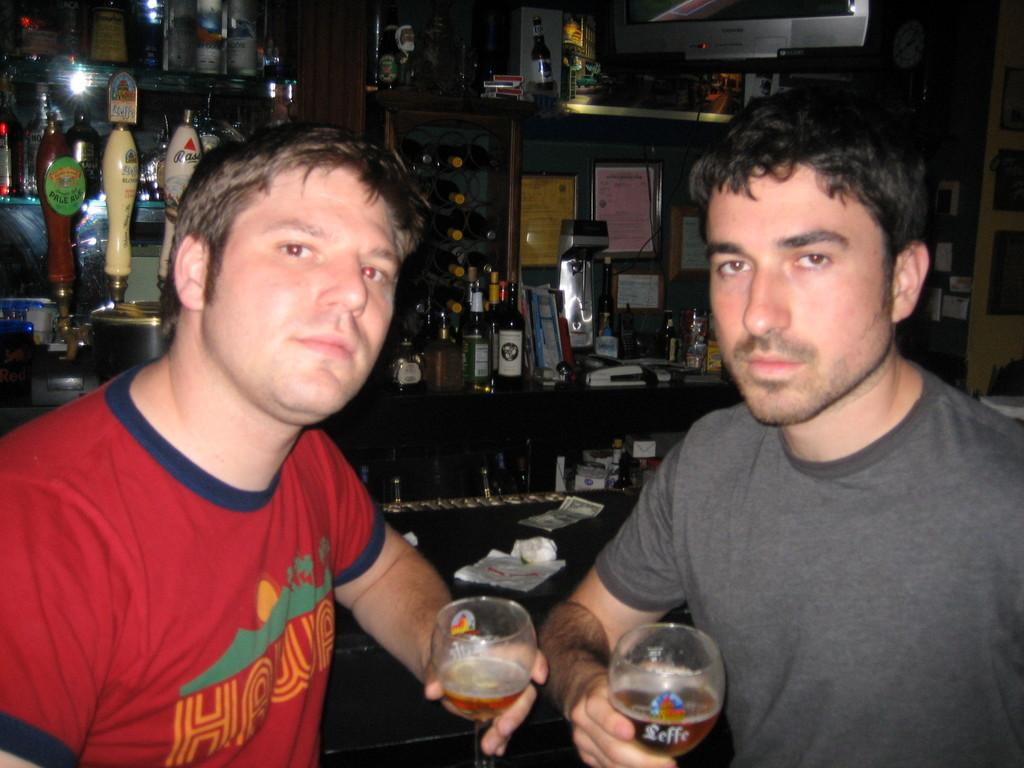How many people are in the image? There are two people in the image. What are the people holding in their hands? The people are holding glasses. What can be seen on the wall in the image? There is a shelf on the wall in the image. What is placed on the shelf? Bottles are placed on the shelf. Are there any other items on the shelf besides the bottles? Yes, there are other things on the shelf. Where is the faucet located in the image? There is no faucet present in the image. What type of hydrant is visible in the image? There is no hydrant present in the image. 